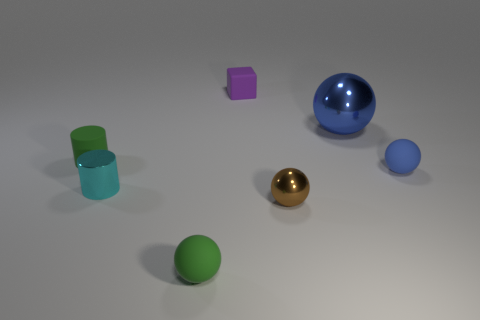The green object in front of the tiny shiny thing that is to the right of the tiny shiny cylinder is what shape? sphere 